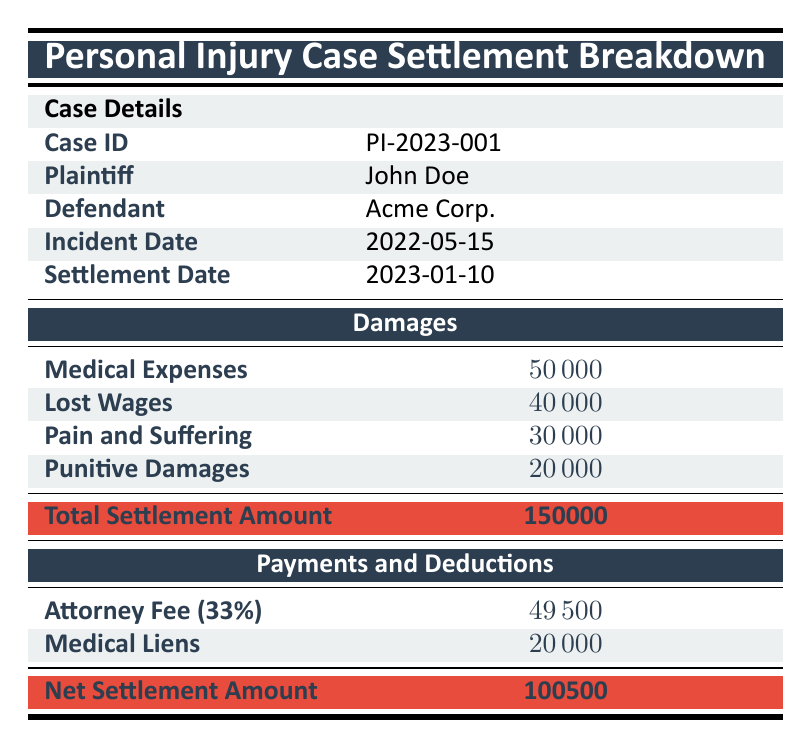What is the total amount of medical expenses listed in the table? The table specifies that the total medical expenses are 50000. I can directly refer to the relevant row under the "Damages" section to find this value.
Answer: 50000 What is the settlement date for this personal injury case? The table provides the settlement date under the "Case Details." I can find it listed as 2023-01-10.
Answer: 2023-01-10 How much of the total settlement amount is allocated to punitive damages? In the damages breakdown, the total for punitive damages is 20000, which can be obtained by locating the relevant row in the "Damages" section.
Answer: 20000 Is the plaintiff's name "John Doe"? The table indicates the plaintiff's name under "Case Details," clearly showing it as John Doe, confirming that the statement is true.
Answer: Yes What is the net settlement amount after deducting the attorney fee and medical liens from the total settlement? To find the net settlement, I need to calculate the deductions: attorney fee (49500) and medical liens (20000), which sum up to 69500. Then, subtract this total from the settlement amount (150000 - 69500), resulting in 100500 for the net settlement.
Answer: 100500 How much does the plaintiff lose in future income according to the breakdown of lost wages? According to the breakdown listed in the table, the future lost income totals 10000. This is found by reviewing the lost wages section where both components are described.
Answer: 10000 What percentage of the total settlement amount represents attorney fees? The attorney fee is stated as 33% of the total settlement amount, which can be confirmed by finding the percentage listed in the payments section.
Answer: 33% What is the total amount listed for lost wages? In the damages section, the total lost wages is specified as 40000, which can be found directly in the relevant row under the "Damages" section.
Answer: 40000 How much are the medical liens broken down into for City Hospital? The breakdown of medical liens indicates that City Hospital is owed 10000, which I can find directly in the relevant breakdown row of payments section.
Answer: 10000 What is the sum of all medical expenses listed in the breakdown? To find the total, I sum up all the amounts listed in the medical expenses breakdown: emergency room visits (15000) + physical therapy (20000) + medications (5000) + follow-up appointments (10000) equals 50000, which matches the total in the main column for medical expenses.
Answer: 50000 